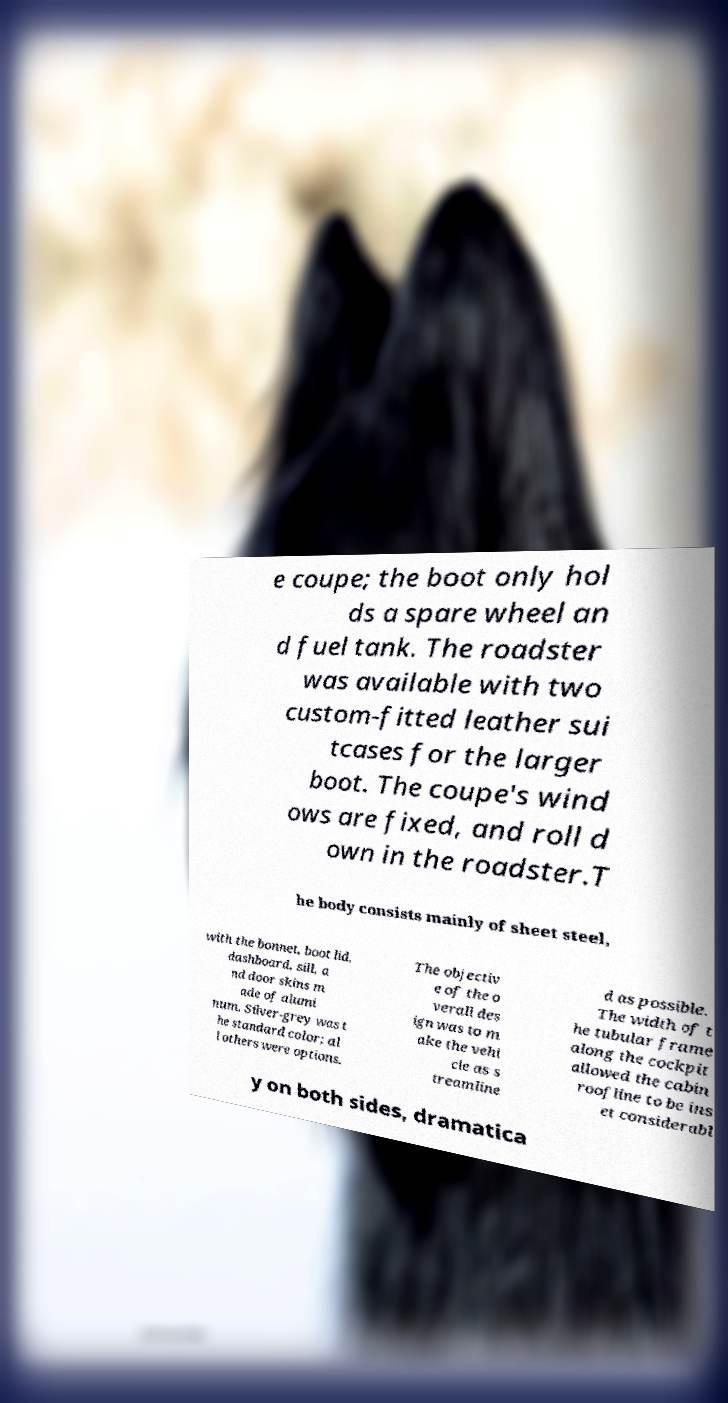Can you accurately transcribe the text from the provided image for me? e coupe; the boot only hol ds a spare wheel an d fuel tank. The roadster was available with two custom-fitted leather sui tcases for the larger boot. The coupe's wind ows are fixed, and roll d own in the roadster.T he body consists mainly of sheet steel, with the bonnet, boot lid, dashboard, sill, a nd door skins m ade of alumi num. Silver-grey was t he standard color; al l others were options. The objectiv e of the o verall des ign was to m ake the vehi cle as s treamline d as possible. The width of t he tubular frame along the cockpit allowed the cabin roofline to be ins et considerabl y on both sides, dramatica 